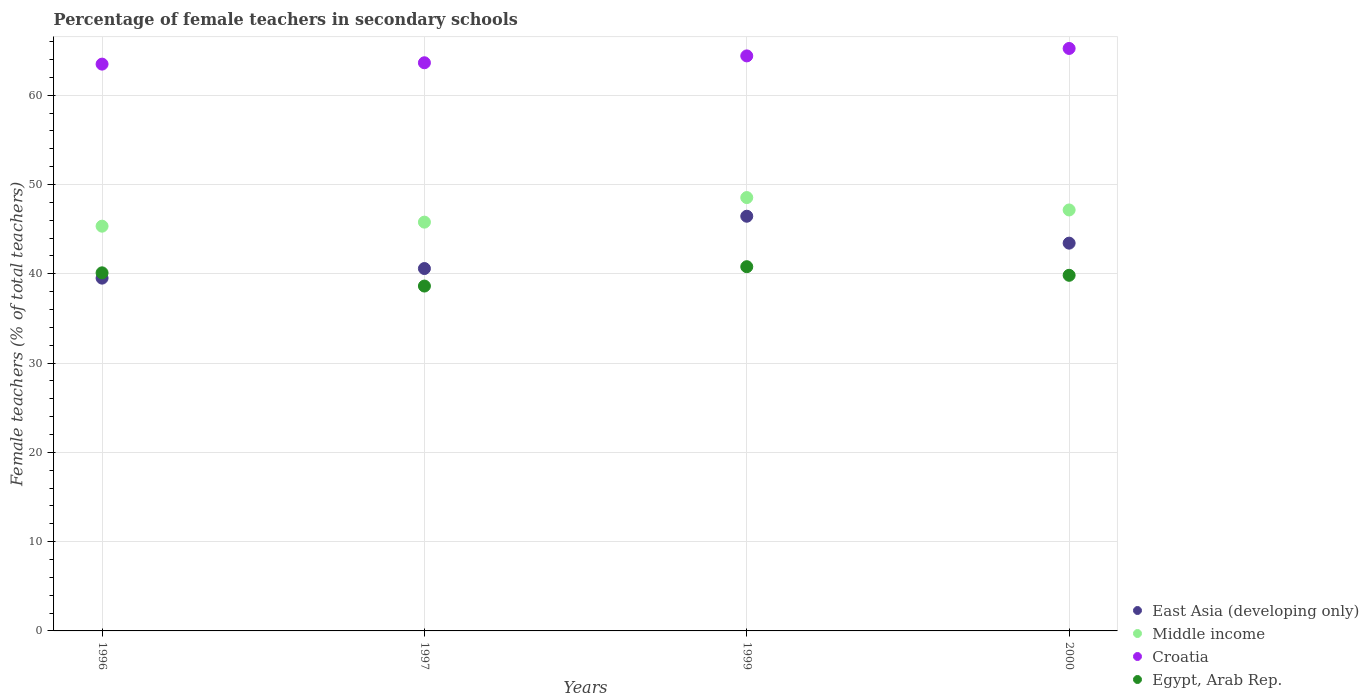What is the percentage of female teachers in East Asia (developing only) in 2000?
Give a very brief answer. 43.43. Across all years, what is the maximum percentage of female teachers in Middle income?
Ensure brevity in your answer.  48.54. Across all years, what is the minimum percentage of female teachers in Middle income?
Provide a succinct answer. 45.33. In which year was the percentage of female teachers in Croatia maximum?
Give a very brief answer. 2000. In which year was the percentage of female teachers in East Asia (developing only) minimum?
Offer a terse response. 1996. What is the total percentage of female teachers in Croatia in the graph?
Your answer should be very brief. 256.75. What is the difference between the percentage of female teachers in East Asia (developing only) in 1997 and that in 2000?
Provide a short and direct response. -2.84. What is the difference between the percentage of female teachers in Egypt, Arab Rep. in 1997 and the percentage of female teachers in Croatia in 1999?
Your answer should be compact. -25.78. What is the average percentage of female teachers in Middle income per year?
Your answer should be compact. 46.7. In the year 1999, what is the difference between the percentage of female teachers in Middle income and percentage of female teachers in Croatia?
Ensure brevity in your answer.  -15.87. In how many years, is the percentage of female teachers in Egypt, Arab Rep. greater than 18 %?
Offer a very short reply. 4. What is the ratio of the percentage of female teachers in Egypt, Arab Rep. in 1999 to that in 2000?
Your answer should be compact. 1.02. Is the percentage of female teachers in Croatia in 1997 less than that in 1999?
Provide a short and direct response. Yes. What is the difference between the highest and the second highest percentage of female teachers in Egypt, Arab Rep.?
Ensure brevity in your answer.  0.69. What is the difference between the highest and the lowest percentage of female teachers in Croatia?
Your answer should be compact. 1.75. Is the sum of the percentage of female teachers in East Asia (developing only) in 1997 and 2000 greater than the maximum percentage of female teachers in Croatia across all years?
Make the answer very short. Yes. Is it the case that in every year, the sum of the percentage of female teachers in Croatia and percentage of female teachers in Egypt, Arab Rep.  is greater than the sum of percentage of female teachers in East Asia (developing only) and percentage of female teachers in Middle income?
Make the answer very short. No. Is it the case that in every year, the sum of the percentage of female teachers in Croatia and percentage of female teachers in Middle income  is greater than the percentage of female teachers in Egypt, Arab Rep.?
Give a very brief answer. Yes. Does the percentage of female teachers in Egypt, Arab Rep. monotonically increase over the years?
Give a very brief answer. No. Is the percentage of female teachers in Egypt, Arab Rep. strictly less than the percentage of female teachers in Middle income over the years?
Keep it short and to the point. Yes. How many years are there in the graph?
Give a very brief answer. 4. Does the graph contain any zero values?
Offer a terse response. No. Where does the legend appear in the graph?
Your response must be concise. Bottom right. How are the legend labels stacked?
Your answer should be compact. Vertical. What is the title of the graph?
Keep it short and to the point. Percentage of female teachers in secondary schools. What is the label or title of the X-axis?
Offer a very short reply. Years. What is the label or title of the Y-axis?
Provide a short and direct response. Female teachers (% of total teachers). What is the Female teachers (% of total teachers) of East Asia (developing only) in 1996?
Keep it short and to the point. 39.51. What is the Female teachers (% of total teachers) of Middle income in 1996?
Your answer should be very brief. 45.33. What is the Female teachers (% of total teachers) of Croatia in 1996?
Ensure brevity in your answer.  63.48. What is the Female teachers (% of total teachers) of Egypt, Arab Rep. in 1996?
Keep it short and to the point. 40.11. What is the Female teachers (% of total teachers) in East Asia (developing only) in 1997?
Offer a terse response. 40.59. What is the Female teachers (% of total teachers) of Middle income in 1997?
Your response must be concise. 45.78. What is the Female teachers (% of total teachers) in Croatia in 1997?
Offer a terse response. 63.63. What is the Female teachers (% of total teachers) of Egypt, Arab Rep. in 1997?
Your response must be concise. 38.62. What is the Female teachers (% of total teachers) of East Asia (developing only) in 1999?
Provide a succinct answer. 46.44. What is the Female teachers (% of total teachers) of Middle income in 1999?
Provide a succinct answer. 48.54. What is the Female teachers (% of total teachers) in Croatia in 1999?
Offer a terse response. 64.4. What is the Female teachers (% of total teachers) in Egypt, Arab Rep. in 1999?
Provide a short and direct response. 40.79. What is the Female teachers (% of total teachers) of East Asia (developing only) in 2000?
Your answer should be compact. 43.43. What is the Female teachers (% of total teachers) in Middle income in 2000?
Your answer should be compact. 47.15. What is the Female teachers (% of total teachers) of Croatia in 2000?
Your answer should be very brief. 65.24. What is the Female teachers (% of total teachers) in Egypt, Arab Rep. in 2000?
Your answer should be compact. 39.83. Across all years, what is the maximum Female teachers (% of total teachers) in East Asia (developing only)?
Ensure brevity in your answer.  46.44. Across all years, what is the maximum Female teachers (% of total teachers) in Middle income?
Your answer should be very brief. 48.54. Across all years, what is the maximum Female teachers (% of total teachers) in Croatia?
Your answer should be very brief. 65.24. Across all years, what is the maximum Female teachers (% of total teachers) in Egypt, Arab Rep.?
Your response must be concise. 40.79. Across all years, what is the minimum Female teachers (% of total teachers) in East Asia (developing only)?
Offer a terse response. 39.51. Across all years, what is the minimum Female teachers (% of total teachers) of Middle income?
Your response must be concise. 45.33. Across all years, what is the minimum Female teachers (% of total teachers) in Croatia?
Your answer should be very brief. 63.48. Across all years, what is the minimum Female teachers (% of total teachers) in Egypt, Arab Rep.?
Your answer should be compact. 38.62. What is the total Female teachers (% of total teachers) in East Asia (developing only) in the graph?
Your response must be concise. 169.97. What is the total Female teachers (% of total teachers) of Middle income in the graph?
Offer a terse response. 186.8. What is the total Female teachers (% of total teachers) of Croatia in the graph?
Provide a succinct answer. 256.75. What is the total Female teachers (% of total teachers) in Egypt, Arab Rep. in the graph?
Offer a very short reply. 159.35. What is the difference between the Female teachers (% of total teachers) in East Asia (developing only) in 1996 and that in 1997?
Your answer should be very brief. -1.07. What is the difference between the Female teachers (% of total teachers) in Middle income in 1996 and that in 1997?
Make the answer very short. -0.45. What is the difference between the Female teachers (% of total teachers) in Croatia in 1996 and that in 1997?
Make the answer very short. -0.15. What is the difference between the Female teachers (% of total teachers) of Egypt, Arab Rep. in 1996 and that in 1997?
Your answer should be very brief. 1.48. What is the difference between the Female teachers (% of total teachers) of East Asia (developing only) in 1996 and that in 1999?
Give a very brief answer. -6.93. What is the difference between the Female teachers (% of total teachers) of Middle income in 1996 and that in 1999?
Your answer should be very brief. -3.2. What is the difference between the Female teachers (% of total teachers) of Croatia in 1996 and that in 1999?
Your response must be concise. -0.92. What is the difference between the Female teachers (% of total teachers) in Egypt, Arab Rep. in 1996 and that in 1999?
Ensure brevity in your answer.  -0.69. What is the difference between the Female teachers (% of total teachers) of East Asia (developing only) in 1996 and that in 2000?
Offer a very short reply. -3.92. What is the difference between the Female teachers (% of total teachers) in Middle income in 1996 and that in 2000?
Your response must be concise. -1.82. What is the difference between the Female teachers (% of total teachers) in Croatia in 1996 and that in 2000?
Your answer should be very brief. -1.75. What is the difference between the Female teachers (% of total teachers) in Egypt, Arab Rep. in 1996 and that in 2000?
Your answer should be compact. 0.28. What is the difference between the Female teachers (% of total teachers) of East Asia (developing only) in 1997 and that in 1999?
Offer a terse response. -5.86. What is the difference between the Female teachers (% of total teachers) in Middle income in 1997 and that in 1999?
Your answer should be very brief. -2.75. What is the difference between the Female teachers (% of total teachers) of Croatia in 1997 and that in 1999?
Offer a terse response. -0.77. What is the difference between the Female teachers (% of total teachers) of Egypt, Arab Rep. in 1997 and that in 1999?
Keep it short and to the point. -2.17. What is the difference between the Female teachers (% of total teachers) in East Asia (developing only) in 1997 and that in 2000?
Offer a very short reply. -2.84. What is the difference between the Female teachers (% of total teachers) in Middle income in 1997 and that in 2000?
Ensure brevity in your answer.  -1.36. What is the difference between the Female teachers (% of total teachers) in Croatia in 1997 and that in 2000?
Provide a succinct answer. -1.6. What is the difference between the Female teachers (% of total teachers) of Egypt, Arab Rep. in 1997 and that in 2000?
Your answer should be very brief. -1.2. What is the difference between the Female teachers (% of total teachers) of East Asia (developing only) in 1999 and that in 2000?
Provide a short and direct response. 3.01. What is the difference between the Female teachers (% of total teachers) in Middle income in 1999 and that in 2000?
Provide a short and direct response. 1.39. What is the difference between the Female teachers (% of total teachers) of Croatia in 1999 and that in 2000?
Offer a very short reply. -0.83. What is the difference between the Female teachers (% of total teachers) in Egypt, Arab Rep. in 1999 and that in 2000?
Give a very brief answer. 0.96. What is the difference between the Female teachers (% of total teachers) in East Asia (developing only) in 1996 and the Female teachers (% of total teachers) in Middle income in 1997?
Your answer should be very brief. -6.27. What is the difference between the Female teachers (% of total teachers) of East Asia (developing only) in 1996 and the Female teachers (% of total teachers) of Croatia in 1997?
Give a very brief answer. -24.12. What is the difference between the Female teachers (% of total teachers) of East Asia (developing only) in 1996 and the Female teachers (% of total teachers) of Egypt, Arab Rep. in 1997?
Give a very brief answer. 0.89. What is the difference between the Female teachers (% of total teachers) of Middle income in 1996 and the Female teachers (% of total teachers) of Croatia in 1997?
Your response must be concise. -18.3. What is the difference between the Female teachers (% of total teachers) of Middle income in 1996 and the Female teachers (% of total teachers) of Egypt, Arab Rep. in 1997?
Ensure brevity in your answer.  6.71. What is the difference between the Female teachers (% of total teachers) of Croatia in 1996 and the Female teachers (% of total teachers) of Egypt, Arab Rep. in 1997?
Your answer should be compact. 24.86. What is the difference between the Female teachers (% of total teachers) in East Asia (developing only) in 1996 and the Female teachers (% of total teachers) in Middle income in 1999?
Provide a short and direct response. -9.02. What is the difference between the Female teachers (% of total teachers) of East Asia (developing only) in 1996 and the Female teachers (% of total teachers) of Croatia in 1999?
Give a very brief answer. -24.89. What is the difference between the Female teachers (% of total teachers) of East Asia (developing only) in 1996 and the Female teachers (% of total teachers) of Egypt, Arab Rep. in 1999?
Your answer should be very brief. -1.28. What is the difference between the Female teachers (% of total teachers) in Middle income in 1996 and the Female teachers (% of total teachers) in Croatia in 1999?
Make the answer very short. -19.07. What is the difference between the Female teachers (% of total teachers) in Middle income in 1996 and the Female teachers (% of total teachers) in Egypt, Arab Rep. in 1999?
Provide a succinct answer. 4.54. What is the difference between the Female teachers (% of total teachers) in Croatia in 1996 and the Female teachers (% of total teachers) in Egypt, Arab Rep. in 1999?
Offer a terse response. 22.69. What is the difference between the Female teachers (% of total teachers) in East Asia (developing only) in 1996 and the Female teachers (% of total teachers) in Middle income in 2000?
Your response must be concise. -7.63. What is the difference between the Female teachers (% of total teachers) of East Asia (developing only) in 1996 and the Female teachers (% of total teachers) of Croatia in 2000?
Provide a succinct answer. -25.72. What is the difference between the Female teachers (% of total teachers) of East Asia (developing only) in 1996 and the Female teachers (% of total teachers) of Egypt, Arab Rep. in 2000?
Give a very brief answer. -0.32. What is the difference between the Female teachers (% of total teachers) of Middle income in 1996 and the Female teachers (% of total teachers) of Croatia in 2000?
Your response must be concise. -19.91. What is the difference between the Female teachers (% of total teachers) of Middle income in 1996 and the Female teachers (% of total teachers) of Egypt, Arab Rep. in 2000?
Your answer should be compact. 5.5. What is the difference between the Female teachers (% of total teachers) of Croatia in 1996 and the Female teachers (% of total teachers) of Egypt, Arab Rep. in 2000?
Offer a terse response. 23.65. What is the difference between the Female teachers (% of total teachers) of East Asia (developing only) in 1997 and the Female teachers (% of total teachers) of Middle income in 1999?
Your answer should be compact. -7.95. What is the difference between the Female teachers (% of total teachers) in East Asia (developing only) in 1997 and the Female teachers (% of total teachers) in Croatia in 1999?
Give a very brief answer. -23.82. What is the difference between the Female teachers (% of total teachers) of East Asia (developing only) in 1997 and the Female teachers (% of total teachers) of Egypt, Arab Rep. in 1999?
Your response must be concise. -0.21. What is the difference between the Female teachers (% of total teachers) of Middle income in 1997 and the Female teachers (% of total teachers) of Croatia in 1999?
Offer a very short reply. -18.62. What is the difference between the Female teachers (% of total teachers) of Middle income in 1997 and the Female teachers (% of total teachers) of Egypt, Arab Rep. in 1999?
Make the answer very short. 4.99. What is the difference between the Female teachers (% of total teachers) of Croatia in 1997 and the Female teachers (% of total teachers) of Egypt, Arab Rep. in 1999?
Give a very brief answer. 22.84. What is the difference between the Female teachers (% of total teachers) of East Asia (developing only) in 1997 and the Female teachers (% of total teachers) of Middle income in 2000?
Provide a succinct answer. -6.56. What is the difference between the Female teachers (% of total teachers) of East Asia (developing only) in 1997 and the Female teachers (% of total teachers) of Croatia in 2000?
Provide a succinct answer. -24.65. What is the difference between the Female teachers (% of total teachers) of East Asia (developing only) in 1997 and the Female teachers (% of total teachers) of Egypt, Arab Rep. in 2000?
Offer a terse response. 0.76. What is the difference between the Female teachers (% of total teachers) in Middle income in 1997 and the Female teachers (% of total teachers) in Croatia in 2000?
Your answer should be compact. -19.45. What is the difference between the Female teachers (% of total teachers) in Middle income in 1997 and the Female teachers (% of total teachers) in Egypt, Arab Rep. in 2000?
Keep it short and to the point. 5.95. What is the difference between the Female teachers (% of total teachers) of Croatia in 1997 and the Female teachers (% of total teachers) of Egypt, Arab Rep. in 2000?
Your answer should be compact. 23.8. What is the difference between the Female teachers (% of total teachers) of East Asia (developing only) in 1999 and the Female teachers (% of total teachers) of Middle income in 2000?
Your answer should be compact. -0.7. What is the difference between the Female teachers (% of total teachers) in East Asia (developing only) in 1999 and the Female teachers (% of total teachers) in Croatia in 2000?
Keep it short and to the point. -18.79. What is the difference between the Female teachers (% of total teachers) of East Asia (developing only) in 1999 and the Female teachers (% of total teachers) of Egypt, Arab Rep. in 2000?
Give a very brief answer. 6.62. What is the difference between the Female teachers (% of total teachers) in Middle income in 1999 and the Female teachers (% of total teachers) in Croatia in 2000?
Ensure brevity in your answer.  -16.7. What is the difference between the Female teachers (% of total teachers) of Middle income in 1999 and the Female teachers (% of total teachers) of Egypt, Arab Rep. in 2000?
Provide a succinct answer. 8.71. What is the difference between the Female teachers (% of total teachers) in Croatia in 1999 and the Female teachers (% of total teachers) in Egypt, Arab Rep. in 2000?
Give a very brief answer. 24.57. What is the average Female teachers (% of total teachers) in East Asia (developing only) per year?
Your answer should be very brief. 42.49. What is the average Female teachers (% of total teachers) in Middle income per year?
Keep it short and to the point. 46.7. What is the average Female teachers (% of total teachers) in Croatia per year?
Offer a very short reply. 64.19. What is the average Female teachers (% of total teachers) of Egypt, Arab Rep. per year?
Your response must be concise. 39.84. In the year 1996, what is the difference between the Female teachers (% of total teachers) in East Asia (developing only) and Female teachers (% of total teachers) in Middle income?
Ensure brevity in your answer.  -5.82. In the year 1996, what is the difference between the Female teachers (% of total teachers) in East Asia (developing only) and Female teachers (% of total teachers) in Croatia?
Offer a very short reply. -23.97. In the year 1996, what is the difference between the Female teachers (% of total teachers) of East Asia (developing only) and Female teachers (% of total teachers) of Egypt, Arab Rep.?
Your answer should be very brief. -0.59. In the year 1996, what is the difference between the Female teachers (% of total teachers) of Middle income and Female teachers (% of total teachers) of Croatia?
Give a very brief answer. -18.15. In the year 1996, what is the difference between the Female teachers (% of total teachers) in Middle income and Female teachers (% of total teachers) in Egypt, Arab Rep.?
Give a very brief answer. 5.22. In the year 1996, what is the difference between the Female teachers (% of total teachers) in Croatia and Female teachers (% of total teachers) in Egypt, Arab Rep.?
Keep it short and to the point. 23.38. In the year 1997, what is the difference between the Female teachers (% of total teachers) of East Asia (developing only) and Female teachers (% of total teachers) of Middle income?
Offer a very short reply. -5.2. In the year 1997, what is the difference between the Female teachers (% of total teachers) of East Asia (developing only) and Female teachers (% of total teachers) of Croatia?
Keep it short and to the point. -23.05. In the year 1997, what is the difference between the Female teachers (% of total teachers) of East Asia (developing only) and Female teachers (% of total teachers) of Egypt, Arab Rep.?
Offer a terse response. 1.96. In the year 1997, what is the difference between the Female teachers (% of total teachers) in Middle income and Female teachers (% of total teachers) in Croatia?
Offer a terse response. -17.85. In the year 1997, what is the difference between the Female teachers (% of total teachers) in Middle income and Female teachers (% of total teachers) in Egypt, Arab Rep.?
Offer a terse response. 7.16. In the year 1997, what is the difference between the Female teachers (% of total teachers) in Croatia and Female teachers (% of total teachers) in Egypt, Arab Rep.?
Make the answer very short. 25.01. In the year 1999, what is the difference between the Female teachers (% of total teachers) in East Asia (developing only) and Female teachers (% of total teachers) in Middle income?
Your answer should be compact. -2.09. In the year 1999, what is the difference between the Female teachers (% of total teachers) of East Asia (developing only) and Female teachers (% of total teachers) of Croatia?
Give a very brief answer. -17.96. In the year 1999, what is the difference between the Female teachers (% of total teachers) of East Asia (developing only) and Female teachers (% of total teachers) of Egypt, Arab Rep.?
Give a very brief answer. 5.65. In the year 1999, what is the difference between the Female teachers (% of total teachers) in Middle income and Female teachers (% of total teachers) in Croatia?
Your answer should be compact. -15.87. In the year 1999, what is the difference between the Female teachers (% of total teachers) of Middle income and Female teachers (% of total teachers) of Egypt, Arab Rep.?
Your answer should be compact. 7.74. In the year 1999, what is the difference between the Female teachers (% of total teachers) of Croatia and Female teachers (% of total teachers) of Egypt, Arab Rep.?
Your response must be concise. 23.61. In the year 2000, what is the difference between the Female teachers (% of total teachers) of East Asia (developing only) and Female teachers (% of total teachers) of Middle income?
Provide a short and direct response. -3.72. In the year 2000, what is the difference between the Female teachers (% of total teachers) in East Asia (developing only) and Female teachers (% of total teachers) in Croatia?
Your answer should be compact. -21.81. In the year 2000, what is the difference between the Female teachers (% of total teachers) of East Asia (developing only) and Female teachers (% of total teachers) of Egypt, Arab Rep.?
Your answer should be compact. 3.6. In the year 2000, what is the difference between the Female teachers (% of total teachers) of Middle income and Female teachers (% of total teachers) of Croatia?
Make the answer very short. -18.09. In the year 2000, what is the difference between the Female teachers (% of total teachers) in Middle income and Female teachers (% of total teachers) in Egypt, Arab Rep.?
Keep it short and to the point. 7.32. In the year 2000, what is the difference between the Female teachers (% of total teachers) of Croatia and Female teachers (% of total teachers) of Egypt, Arab Rep.?
Keep it short and to the point. 25.41. What is the ratio of the Female teachers (% of total teachers) of East Asia (developing only) in 1996 to that in 1997?
Provide a succinct answer. 0.97. What is the ratio of the Female teachers (% of total teachers) of Egypt, Arab Rep. in 1996 to that in 1997?
Offer a very short reply. 1.04. What is the ratio of the Female teachers (% of total teachers) of East Asia (developing only) in 1996 to that in 1999?
Give a very brief answer. 0.85. What is the ratio of the Female teachers (% of total teachers) of Middle income in 1996 to that in 1999?
Keep it short and to the point. 0.93. What is the ratio of the Female teachers (% of total teachers) of Croatia in 1996 to that in 1999?
Give a very brief answer. 0.99. What is the ratio of the Female teachers (% of total teachers) of Egypt, Arab Rep. in 1996 to that in 1999?
Keep it short and to the point. 0.98. What is the ratio of the Female teachers (% of total teachers) of East Asia (developing only) in 1996 to that in 2000?
Provide a short and direct response. 0.91. What is the ratio of the Female teachers (% of total teachers) of Middle income in 1996 to that in 2000?
Your answer should be very brief. 0.96. What is the ratio of the Female teachers (% of total teachers) in Croatia in 1996 to that in 2000?
Make the answer very short. 0.97. What is the ratio of the Female teachers (% of total teachers) in Egypt, Arab Rep. in 1996 to that in 2000?
Give a very brief answer. 1.01. What is the ratio of the Female teachers (% of total teachers) of East Asia (developing only) in 1997 to that in 1999?
Offer a terse response. 0.87. What is the ratio of the Female teachers (% of total teachers) of Middle income in 1997 to that in 1999?
Your answer should be very brief. 0.94. What is the ratio of the Female teachers (% of total teachers) of Croatia in 1997 to that in 1999?
Keep it short and to the point. 0.99. What is the ratio of the Female teachers (% of total teachers) of Egypt, Arab Rep. in 1997 to that in 1999?
Your answer should be compact. 0.95. What is the ratio of the Female teachers (% of total teachers) of East Asia (developing only) in 1997 to that in 2000?
Make the answer very short. 0.93. What is the ratio of the Female teachers (% of total teachers) of Middle income in 1997 to that in 2000?
Your answer should be compact. 0.97. What is the ratio of the Female teachers (% of total teachers) in Croatia in 1997 to that in 2000?
Your answer should be very brief. 0.98. What is the ratio of the Female teachers (% of total teachers) in Egypt, Arab Rep. in 1997 to that in 2000?
Your response must be concise. 0.97. What is the ratio of the Female teachers (% of total teachers) of East Asia (developing only) in 1999 to that in 2000?
Your response must be concise. 1.07. What is the ratio of the Female teachers (% of total teachers) of Middle income in 1999 to that in 2000?
Offer a terse response. 1.03. What is the ratio of the Female teachers (% of total teachers) of Croatia in 1999 to that in 2000?
Provide a succinct answer. 0.99. What is the ratio of the Female teachers (% of total teachers) of Egypt, Arab Rep. in 1999 to that in 2000?
Offer a very short reply. 1.02. What is the difference between the highest and the second highest Female teachers (% of total teachers) in East Asia (developing only)?
Ensure brevity in your answer.  3.01. What is the difference between the highest and the second highest Female teachers (% of total teachers) in Middle income?
Your response must be concise. 1.39. What is the difference between the highest and the second highest Female teachers (% of total teachers) of Croatia?
Your answer should be compact. 0.83. What is the difference between the highest and the second highest Female teachers (% of total teachers) of Egypt, Arab Rep.?
Give a very brief answer. 0.69. What is the difference between the highest and the lowest Female teachers (% of total teachers) in East Asia (developing only)?
Your answer should be very brief. 6.93. What is the difference between the highest and the lowest Female teachers (% of total teachers) of Middle income?
Your answer should be very brief. 3.2. What is the difference between the highest and the lowest Female teachers (% of total teachers) of Croatia?
Offer a very short reply. 1.75. What is the difference between the highest and the lowest Female teachers (% of total teachers) of Egypt, Arab Rep.?
Keep it short and to the point. 2.17. 